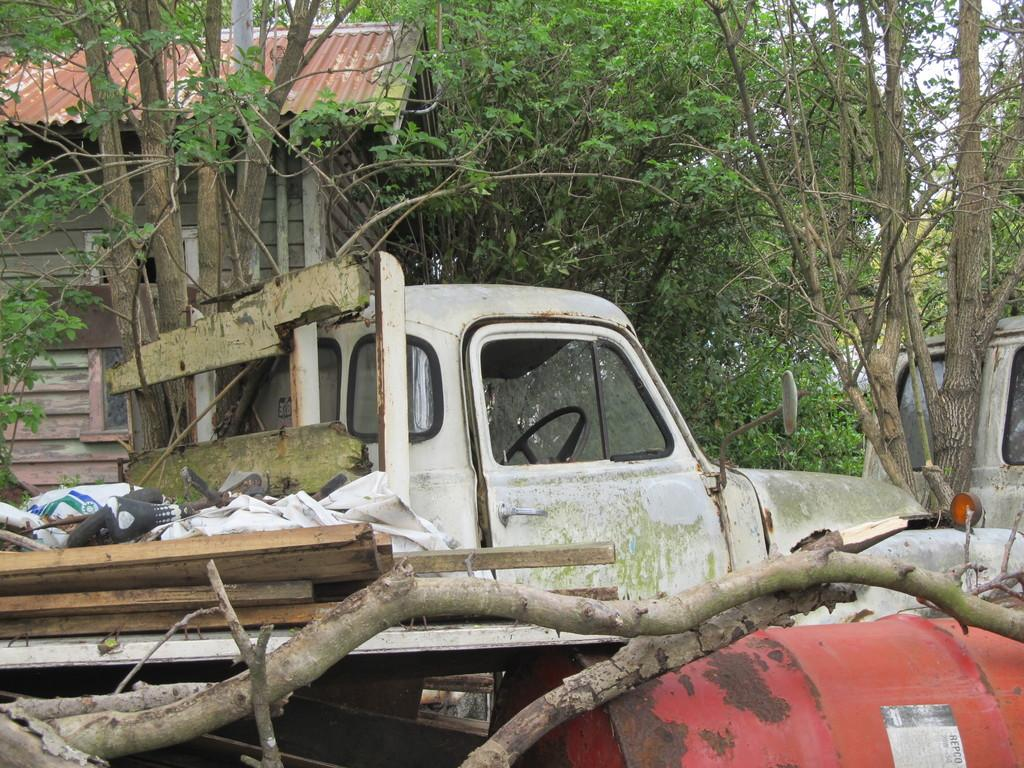What is the main subject of the image? There is a vehicle in the image. What can be seen in the background of the image? There are branches and trees in the image. What type of structure is present in the image? There is a house in the image. What type of eggnog is being served at the house in the image? There is no mention of eggnog or any food or drink in the image. The focus is on the vehicle, branches, trees, and house. 